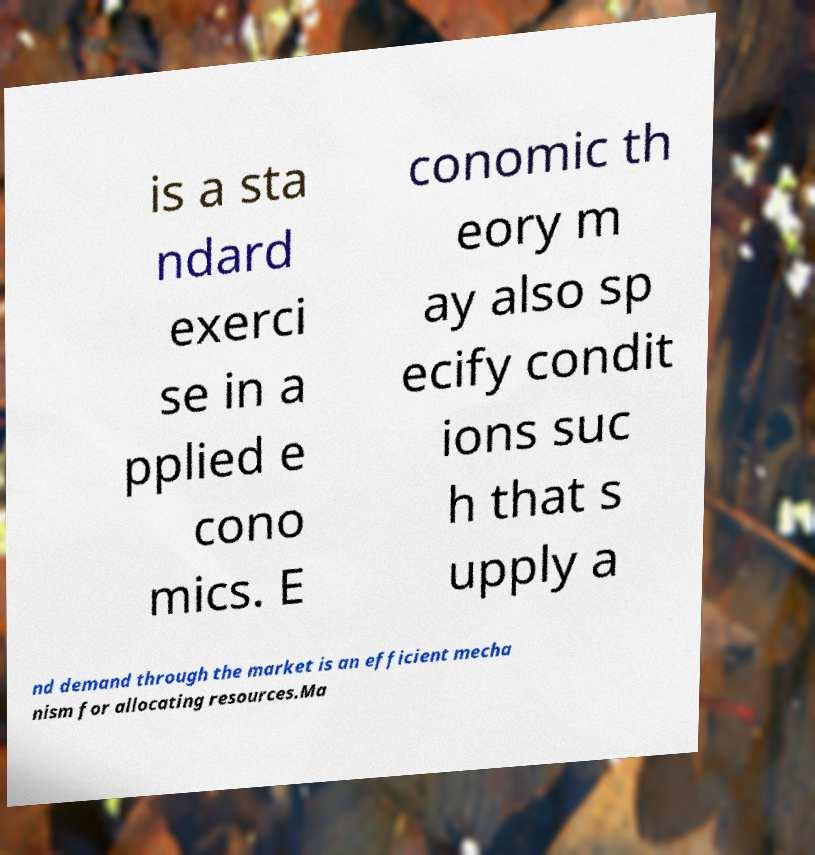There's text embedded in this image that I need extracted. Can you transcribe it verbatim? is a sta ndard exerci se in a pplied e cono mics. E conomic th eory m ay also sp ecify condit ions suc h that s upply a nd demand through the market is an efficient mecha nism for allocating resources.Ma 